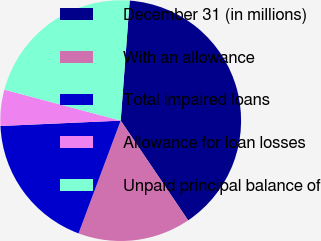Convert chart. <chart><loc_0><loc_0><loc_500><loc_500><pie_chart><fcel>December 31 (in millions)<fcel>With an allowance<fcel>Total impaired loans<fcel>Allowance for loan losses<fcel>Unpaid principal balance of<nl><fcel>39.35%<fcel>15.15%<fcel>18.6%<fcel>4.85%<fcel>22.05%<nl></chart> 